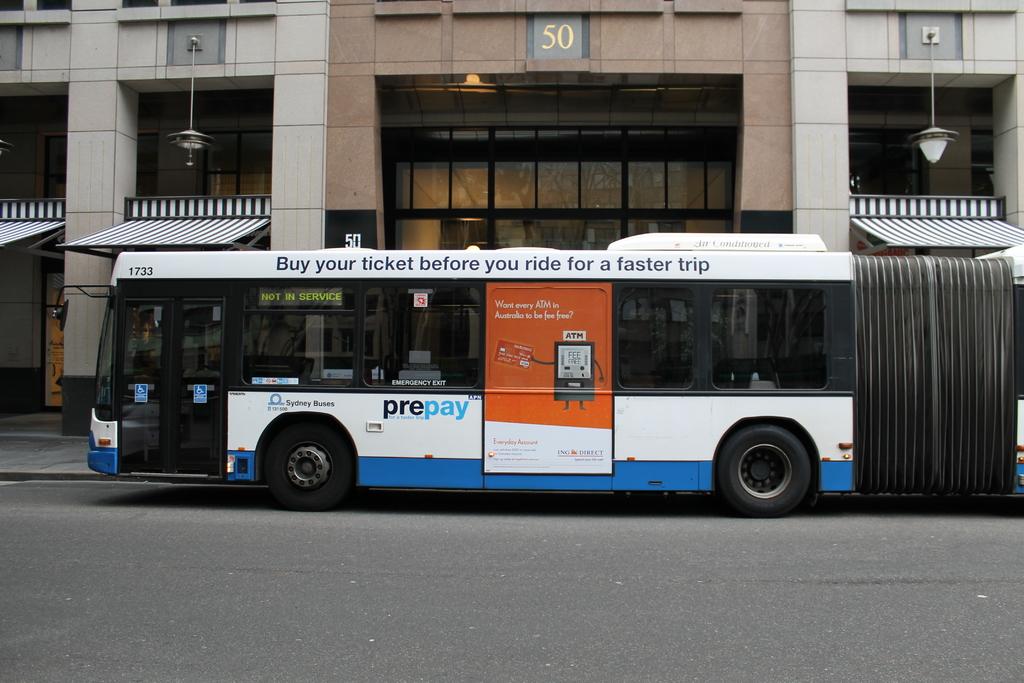What should you do if you would like a faster trip?
Your answer should be compact. Buy your ticket before you ride. In what city is this bus?
Keep it short and to the point. Sydney. 